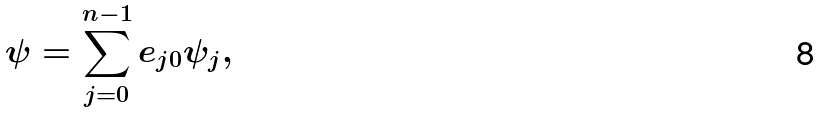<formula> <loc_0><loc_0><loc_500><loc_500>\psi = \sum _ { j = 0 } ^ { n - 1 } e _ { j 0 } \psi _ { j } ,</formula> 